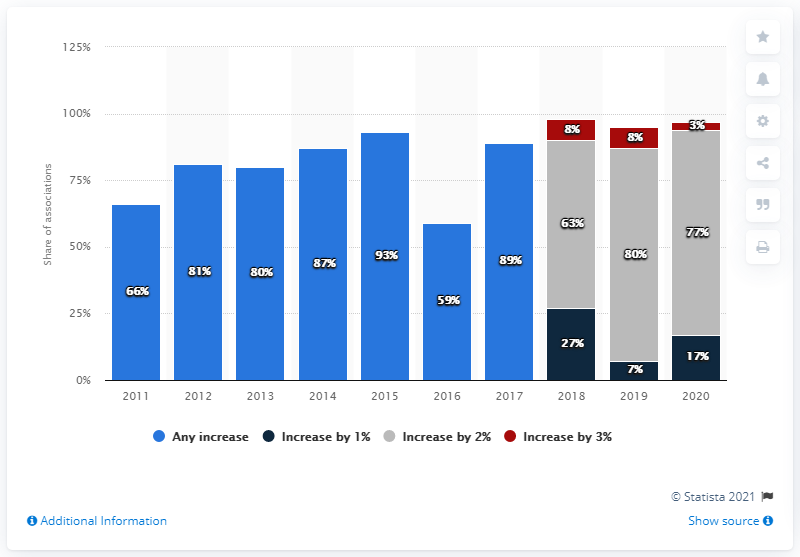Identify some key points in this picture. In 2020, fewer respondents budgeted for salary increases compared to previous years. 